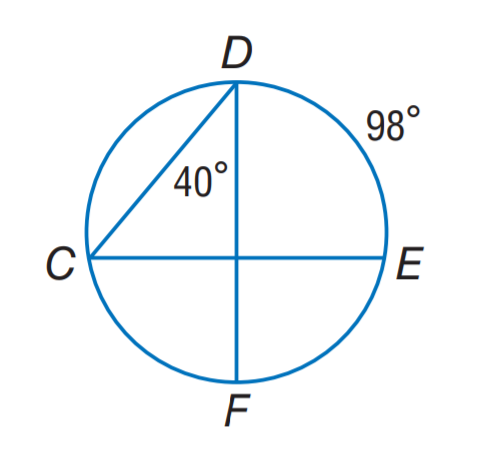Answer the mathemtical geometry problem and directly provide the correct option letter.
Question: Find m \widehat C F.
Choices: A: 40 B: 49 C: 80 D: 98 C 